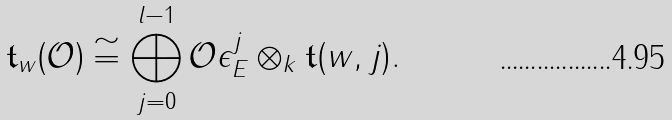<formula> <loc_0><loc_0><loc_500><loc_500>\mathfrak t _ { w } ( \mathcal { O } ) \cong \bigoplus _ { j = 0 } ^ { l - 1 } \mathcal { O } \epsilon ^ { j } _ { E } \otimes _ { k } \mathfrak t ( w , j ) .</formula> 